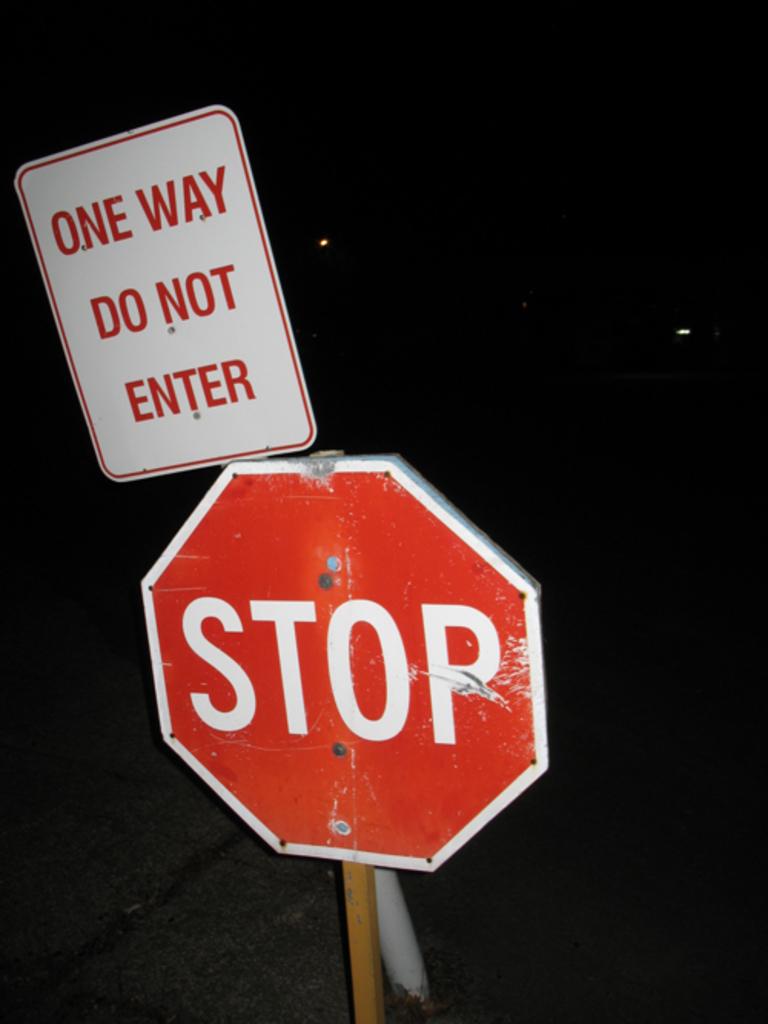What is the sign used for?
Your response must be concise. Stop. Are you supposed to enter?
Provide a succinct answer. No. 